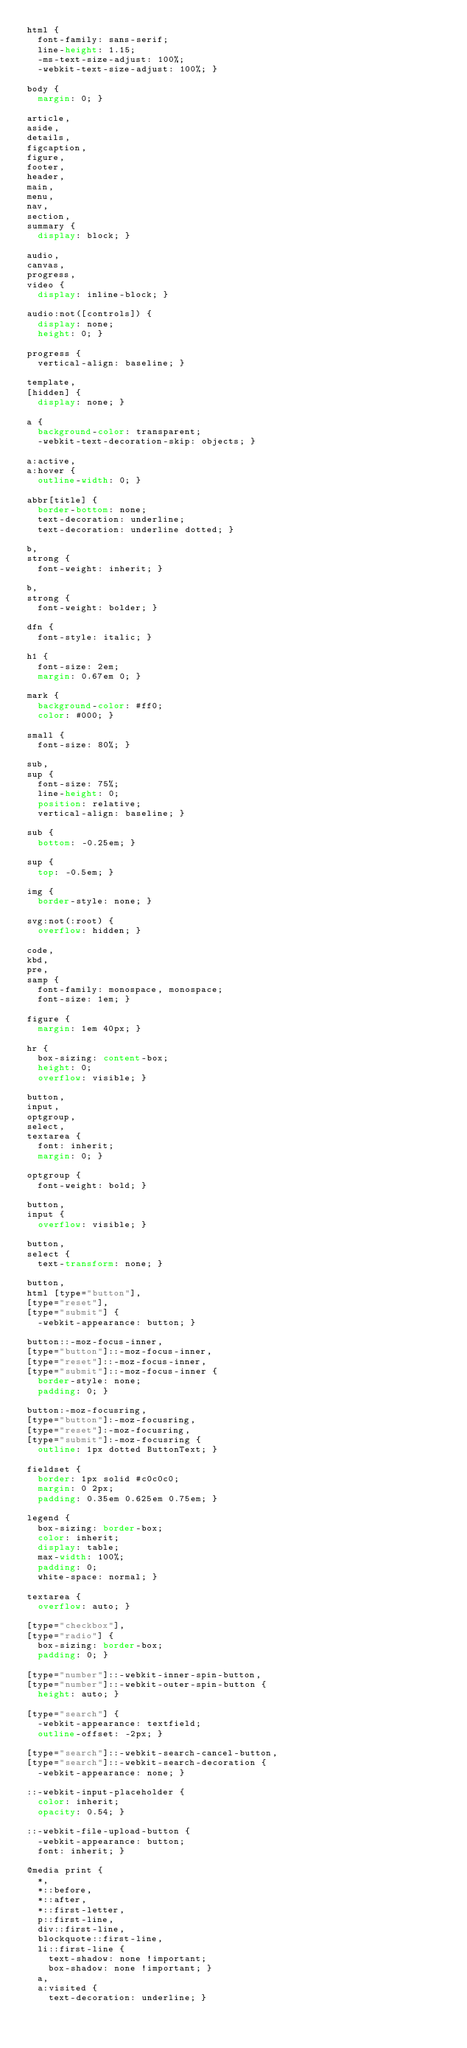<code> <loc_0><loc_0><loc_500><loc_500><_CSS_>html {
  font-family: sans-serif;
  line-height: 1.15;
  -ms-text-size-adjust: 100%;
  -webkit-text-size-adjust: 100%; }

body {
  margin: 0; }

article,
aside,
details,
figcaption,
figure,
footer,
header,
main,
menu,
nav,
section,
summary {
  display: block; }

audio,
canvas,
progress,
video {
  display: inline-block; }

audio:not([controls]) {
  display: none;
  height: 0; }

progress {
  vertical-align: baseline; }

template,
[hidden] {
  display: none; }

a {
  background-color: transparent;
  -webkit-text-decoration-skip: objects; }

a:active,
a:hover {
  outline-width: 0; }

abbr[title] {
  border-bottom: none;
  text-decoration: underline;
  text-decoration: underline dotted; }

b,
strong {
  font-weight: inherit; }

b,
strong {
  font-weight: bolder; }

dfn {
  font-style: italic; }

h1 {
  font-size: 2em;
  margin: 0.67em 0; }

mark {
  background-color: #ff0;
  color: #000; }

small {
  font-size: 80%; }

sub,
sup {
  font-size: 75%;
  line-height: 0;
  position: relative;
  vertical-align: baseline; }

sub {
  bottom: -0.25em; }

sup {
  top: -0.5em; }

img {
  border-style: none; }

svg:not(:root) {
  overflow: hidden; }

code,
kbd,
pre,
samp {
  font-family: monospace, monospace;
  font-size: 1em; }

figure {
  margin: 1em 40px; }

hr {
  box-sizing: content-box;
  height: 0;
  overflow: visible; }

button,
input,
optgroup,
select,
textarea {
  font: inherit;
  margin: 0; }

optgroup {
  font-weight: bold; }

button,
input {
  overflow: visible; }

button,
select {
  text-transform: none; }

button,
html [type="button"],
[type="reset"],
[type="submit"] {
  -webkit-appearance: button; }

button::-moz-focus-inner,
[type="button"]::-moz-focus-inner,
[type="reset"]::-moz-focus-inner,
[type="submit"]::-moz-focus-inner {
  border-style: none;
  padding: 0; }

button:-moz-focusring,
[type="button"]:-moz-focusring,
[type="reset"]:-moz-focusring,
[type="submit"]:-moz-focusring {
  outline: 1px dotted ButtonText; }

fieldset {
  border: 1px solid #c0c0c0;
  margin: 0 2px;
  padding: 0.35em 0.625em 0.75em; }

legend {
  box-sizing: border-box;
  color: inherit;
  display: table;
  max-width: 100%;
  padding: 0;
  white-space: normal; }

textarea {
  overflow: auto; }

[type="checkbox"],
[type="radio"] {
  box-sizing: border-box;
  padding: 0; }

[type="number"]::-webkit-inner-spin-button,
[type="number"]::-webkit-outer-spin-button {
  height: auto; }

[type="search"] {
  -webkit-appearance: textfield;
  outline-offset: -2px; }

[type="search"]::-webkit-search-cancel-button,
[type="search"]::-webkit-search-decoration {
  -webkit-appearance: none; }

::-webkit-input-placeholder {
  color: inherit;
  opacity: 0.54; }

::-webkit-file-upload-button {
  -webkit-appearance: button;
  font: inherit; }

@media print {
  *,
  *::before,
  *::after,
  *::first-letter,
  p::first-line,
  div::first-line,
  blockquote::first-line,
  li::first-line {
    text-shadow: none !important;
    box-shadow: none !important; }
  a,
  a:visited {
    text-decoration: underline; }</code> 